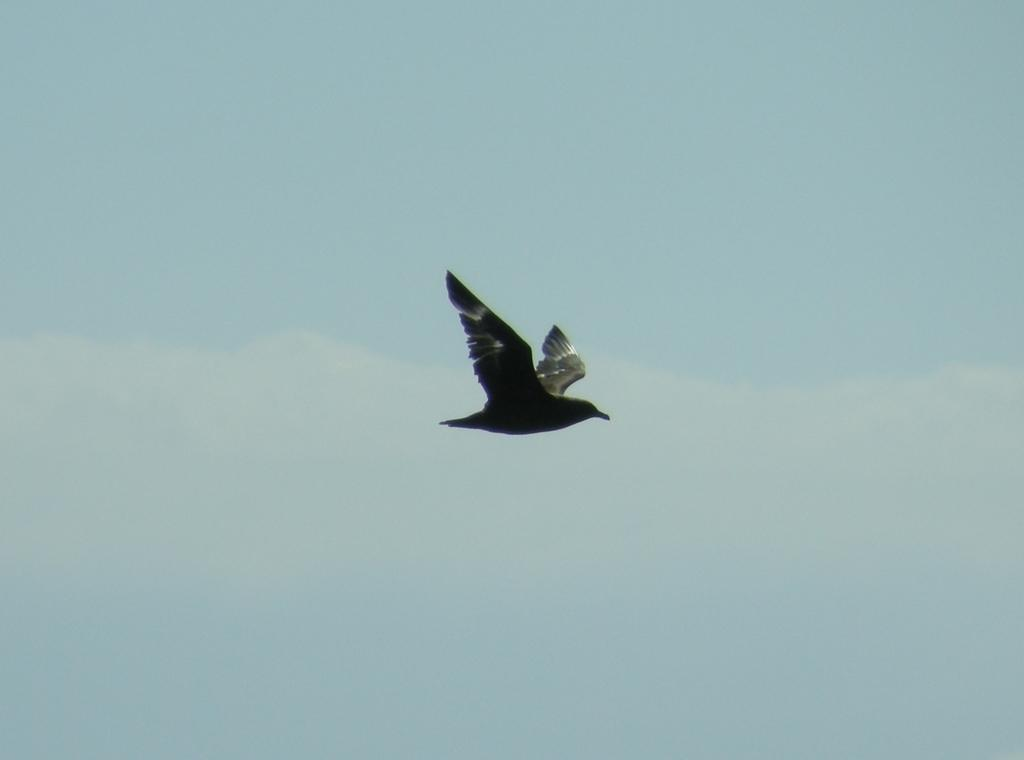What type of animal can be seen in the image? There is a bird in the image. What is the bird doing in the image? The bird is flying in the air. What can be seen in the background of the image? There is sky visible in the background of the image. What else is present in the sky? Clouds are present in the sky. What type of stew is the bird preparing in the image? There is no stew present in the image, and the bird is not shown preparing any food. 